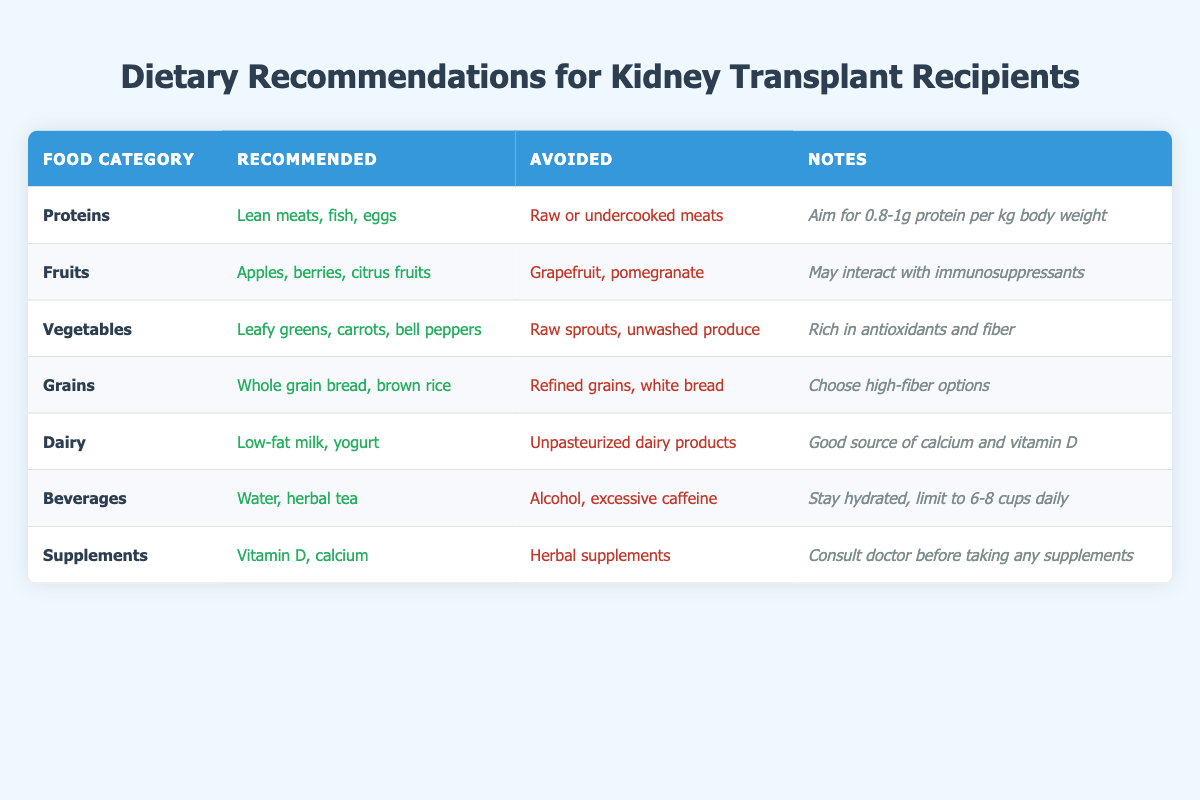What protein sources are recommended for kidney transplant recipients? The table indicates that kidney transplant recipients should consume lean meats, fish, and eggs as their protein sources. This is found in the "Recommended" column for the "Proteins" food category.
Answer: Lean meats, fish, eggs What types of fruits should be avoided by kidney transplant recipients? The foods to avoid under the "Fruits" category are grapefruit and pomegranate. This information is directly available in the "Avoided" column for that category.
Answer: Grapefruit, pomegranate Is it safe for kidney transplant recipients to consume raw sprouts? According to the "Vegetables" category, raw sprouts are listed under the "Avoided" foods, indicating that it is not safe for kidney transplant recipients to eat them.
Answer: No What is the recommended fluid intake for kidney transplant recipients per day? The "Beverages" category states that kidney transplant recipients should stay hydrated and limit their intake to 6-8 cups daily. This information is in the "Notes" column.
Answer: 6-8 cups Are whole grain products recommended for kidney transplant recipients? Yes, the "Grains" category recommends whole grain bread and brown rice, which means whole grain products are encouraged in their diet.
Answer: Yes What type of dairy is recommended for kidney transplant recipients, and what should they avoid? The "Dairy" section indicates that low-fat milk and yogurt are recommended, while unpasteurized dairy products are to be avoided. These details can be found in the "Recommended" and "Avoided" columns respectively.
Answer: Low-fat milk, yogurt; unpasteurized dairy products What supplements should kidney transplant recipients consider? The "Supplements" category recommends vitamin D and calcium, indicating what these individuals should take. This is found in the "Recommended" column.
Answer: Vitamin D, calcium How do the recommended vegetable choices contribute to a kidney transplant recipient's diet? The "Vegetables" category suggests leafy greens, carrots, and bell peppers. The notes state they are rich in antioxidants and fiber, contributing positively to the diet. This involves understanding the benefits of these recommended foods.
Answer: Rich in antioxidants and fiber How does the protein recommendation of 0.8-1g per kg body weight relate to the kidney transplant recipient's diet? The note under the "Proteins" category specifies the amount of protein intake relative to body weight, suggesting careful calculation is necessary based on the recipient's weight, indicating a tailored approach to diet management after transplant. This requires understanding how to calculate protein needs based on body weight.
Answer: 0.8-1g protein per kg body weight 